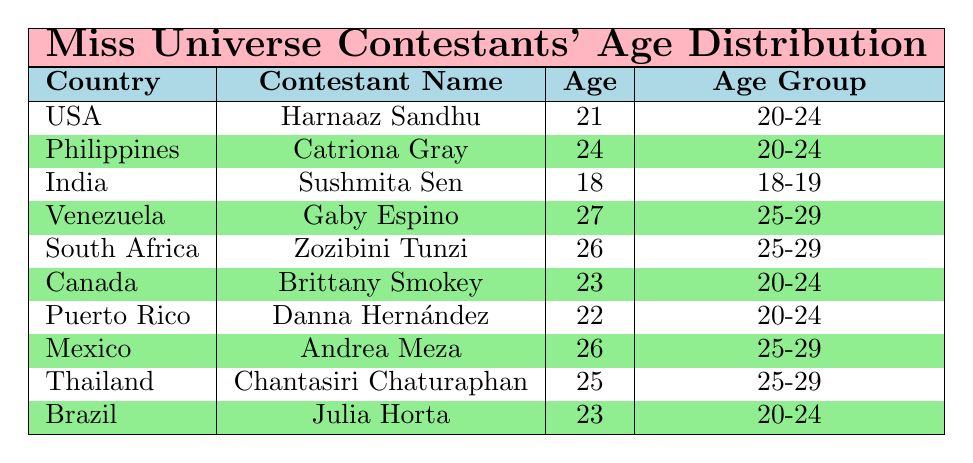What is the age of the contestant from India? The table shows that the contestant from India is Sushmita Sen, who is 18 years old.
Answer: 18 How many contestants fall into the age group of 20-24? The contestants in the age group of 20-24 are Harnaaz Sandhu (21), Catriona Gray (24), Brittany Smokey (23), Danna Hernández (22), and Julia Horta (23), totaling 5 contestants.
Answer: 5 Is there a contestant from Venezuela aged 27? Yes, the table indicates that Gaby Espino from Venezuela is aged 27.
Answer: Yes What age group does Zozibini Tunzi belong to? The table states that Zozibini Tunzi, from South Africa, is 26 years old, which places her in the age group of 25-29.
Answer: 25-29 What is the average age of contestants in the 25-29 age group? The contestants in the 25-29 age group are Gaby Espino (27), Zozibini Tunzi (26), Andrea Meza (26), and Chantasiri Chaturaphan (25). Summing their ages gives (27 + 26 + 26 + 25) = 104. There are 4 contestants, so the average age is 104 / 4 = 26.
Answer: 26 Which country has the contestant with the highest age? Looking at the ages in the table, Gaby Espino from Venezuela, who is 27 years old, has the highest age.
Answer: Venezuela How many contestants are from countries in the age group 18-19? The table indicates that only Sushmita Sen from India fits into the 18-19 age group, totaling 1 contestant.
Answer: 1 Are there more contestants in the 25-29 age group than in the 20-24 age group? The 20-24 age group has 5 contestants (Harnaaz Sandhu, Catriona Gray, Brittany Smokey, Danna Hernández, Julia Horta) while the 25-29 age group has 4 contestants (Gaby Espino, Zozibini Tunzi, Andrea Meza, Chantasiri Chaturaphan). Therefore, there are more contestants in the 20-24 age group.
Answer: No What is the total number of contestants from North America? The contestants from North America are Brittany Smokey from Canada and Danna Hernández from Puerto Rico, giving a total of 2 contestants.
Answer: 2 